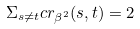<formula> <loc_0><loc_0><loc_500><loc_500>\Sigma _ { s \neq t } c r _ { \beta ^ { 2 } } ( s , t ) = 2</formula> 